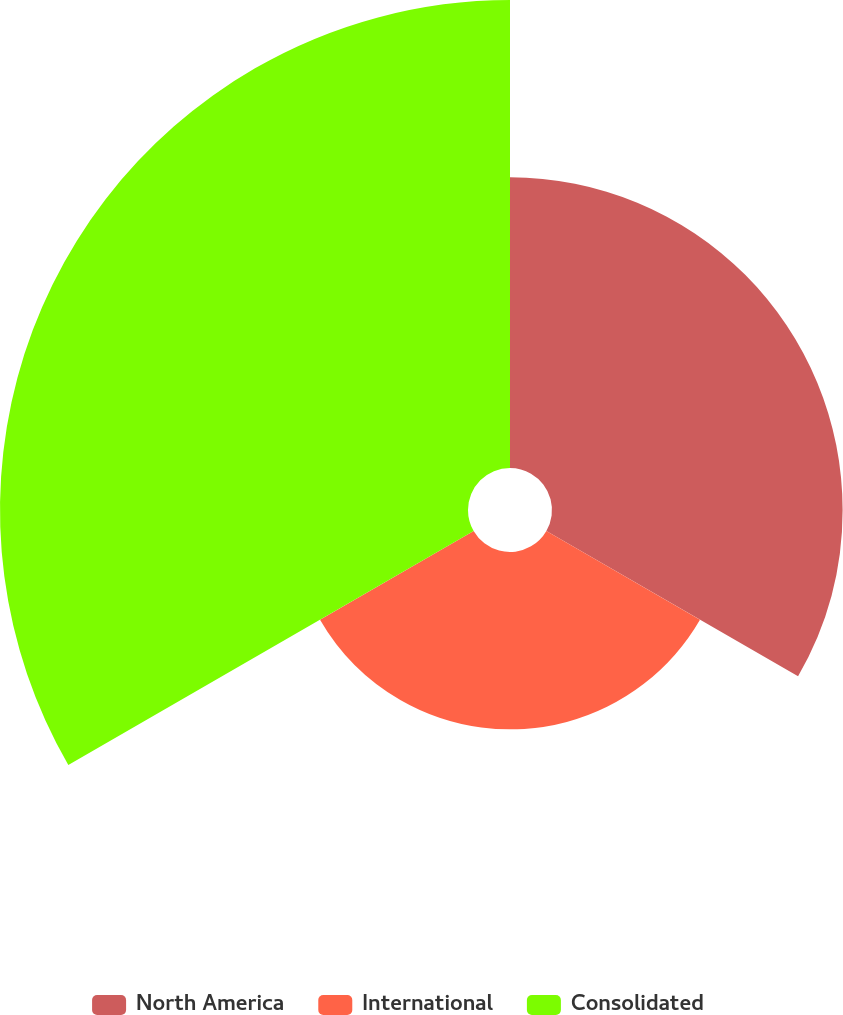Convert chart. <chart><loc_0><loc_0><loc_500><loc_500><pie_chart><fcel>North America<fcel>International<fcel>Consolidated<nl><fcel>31.05%<fcel>18.95%<fcel>50.0%<nl></chart> 